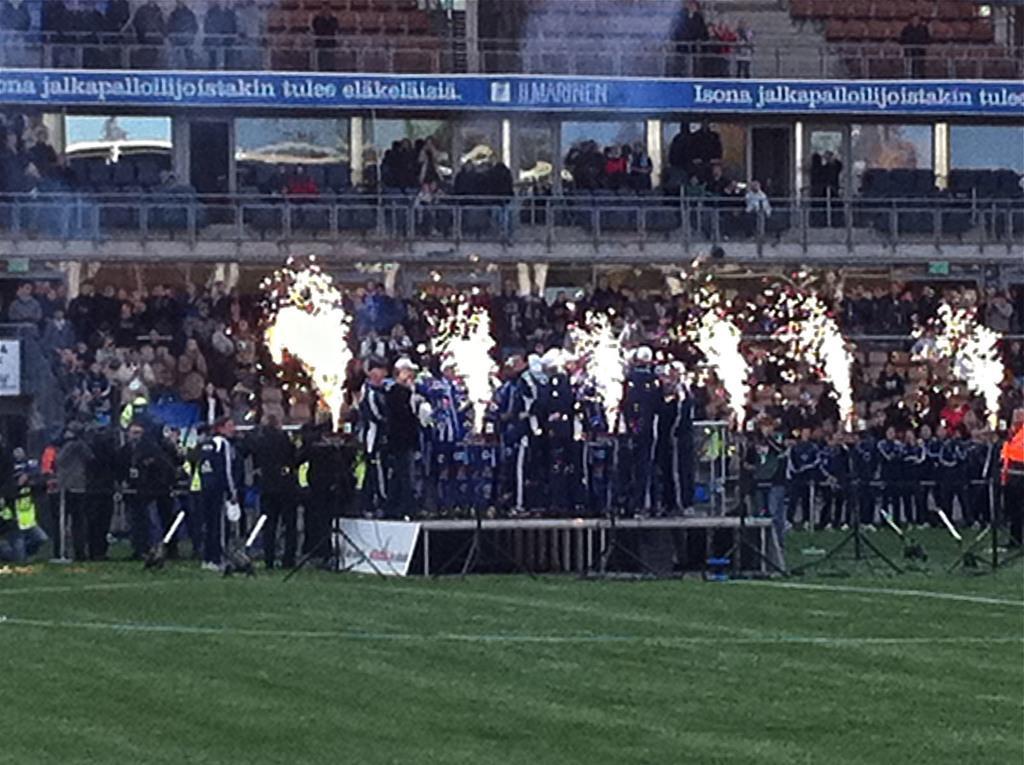In one or two sentences, can you explain what this image depicts? In this image, we can see people and there are crackers and there is a stage. In the background, there is a building. At the bottom, there is ground. 